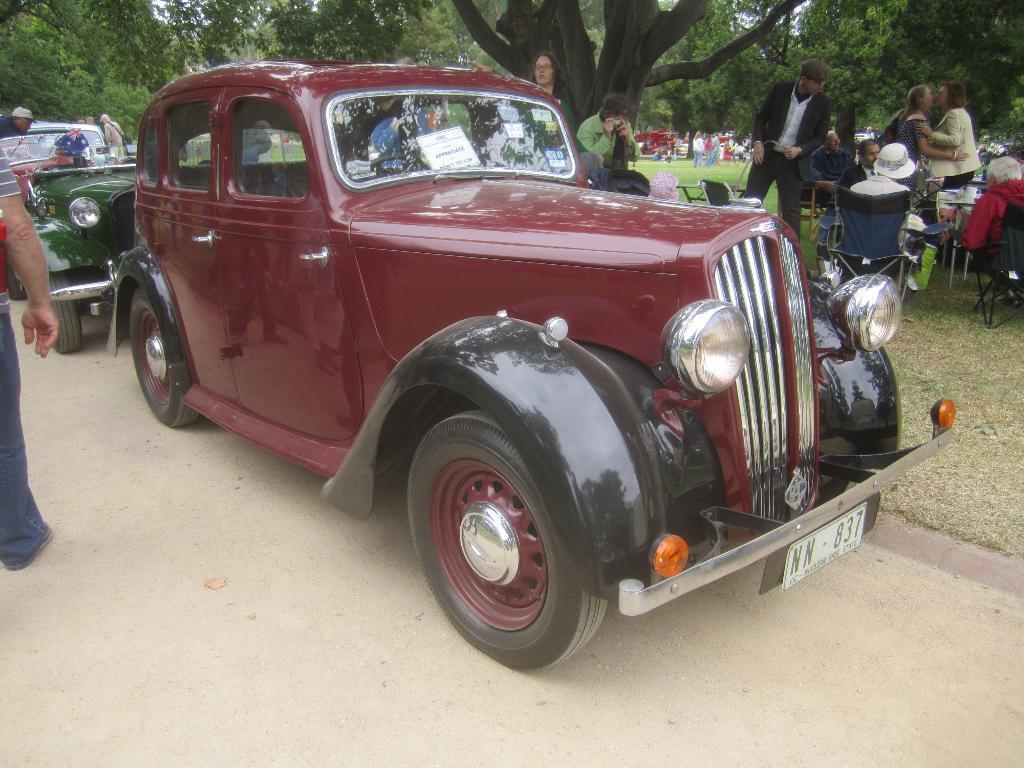Could you give a brief overview of what you see in this image? In the center of the image there is a car on a road. In the background of the image there are people sitting on chairs and there are trees. 